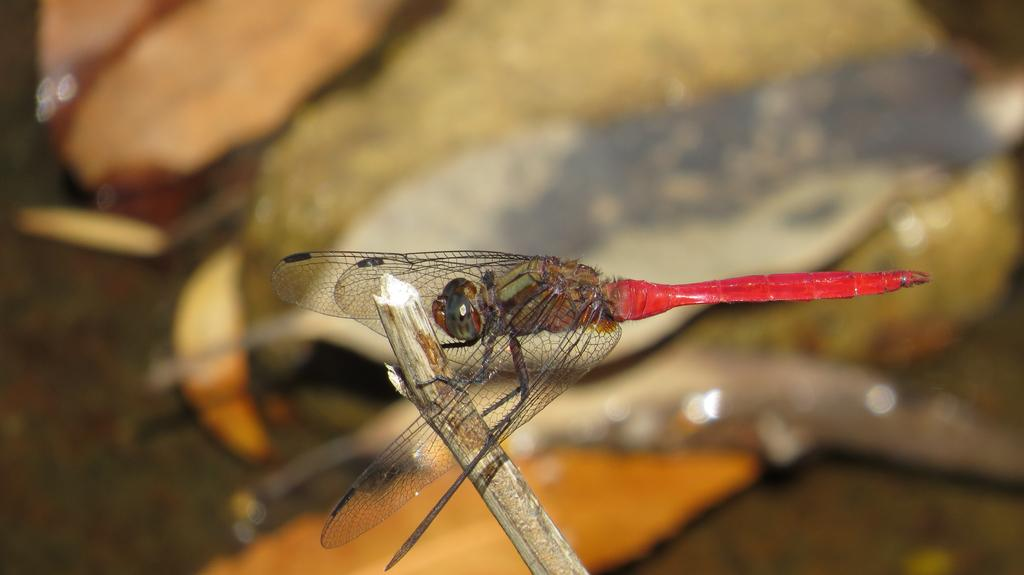What is the main subject of the image? The main subject of the image is a dragonfly. What is the dragonfly resting on in the image? The dragonfly is on a stick. Can you describe the background of the image? The background of the image is blurred. What type of coast can be seen in the image? There is no coast present in the image; it features a dragonfly on a stick with a blurred background. Where is the recess located in the image? There is no recess present in the image. What type of machine is visible in the image? There is no machine present in the image. 